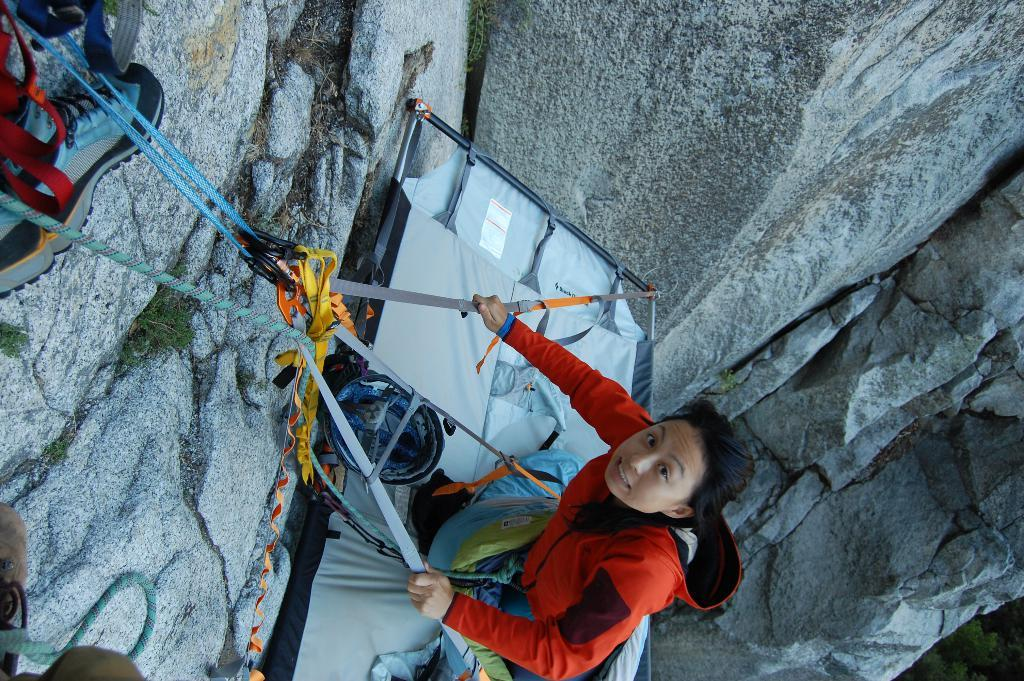Who is the main subject in the image? There is a woman in the image. What is the woman holding in the image? The woman is holding a rope. What can be seen in the background of the image? There are rocks visible in the background of the image. What type of lift is the woman operating in the image? There is no lift present in the image; the woman is holding a rope. What medical advice is the doctor giving to the woman in the image? There is no doctor present in the image; it only features a woman holding a rope. 